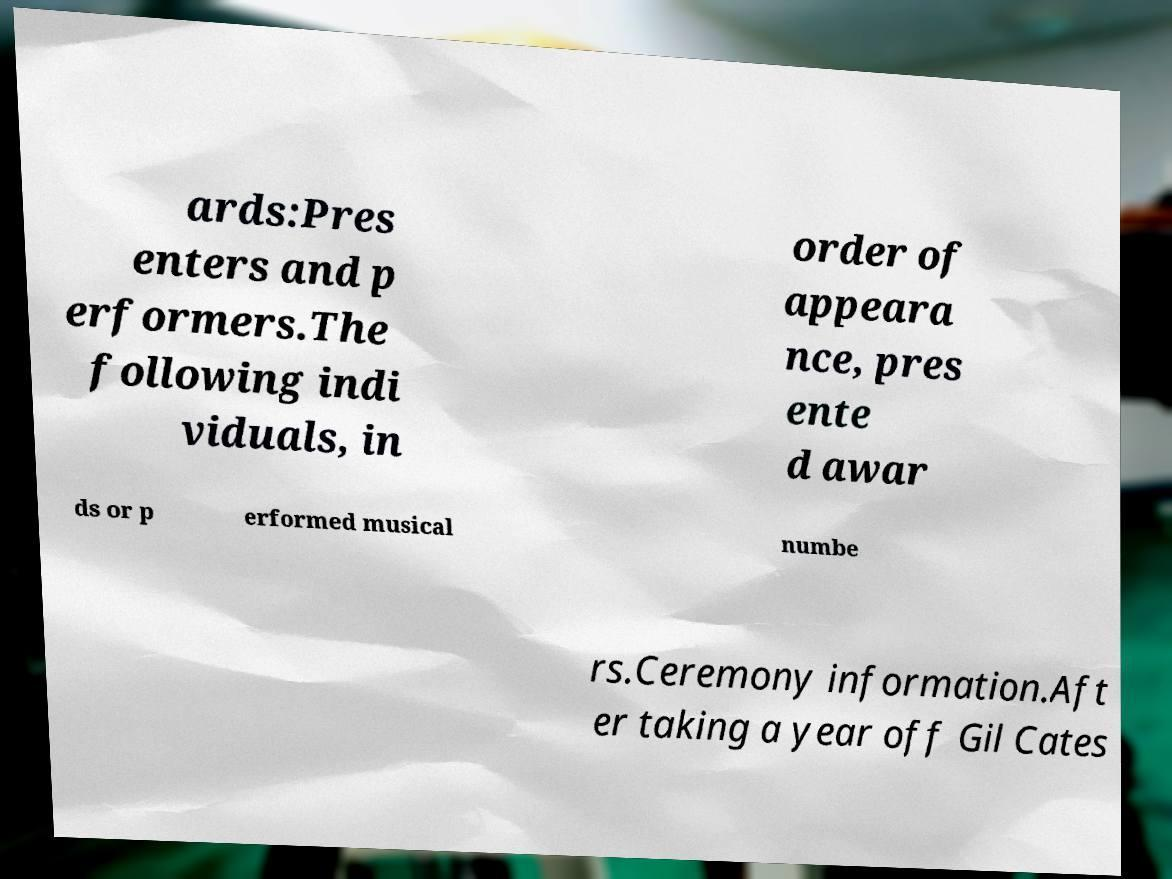Please identify and transcribe the text found in this image. ards:Pres enters and p erformers.The following indi viduals, in order of appeara nce, pres ente d awar ds or p erformed musical numbe rs.Ceremony information.Aft er taking a year off Gil Cates 